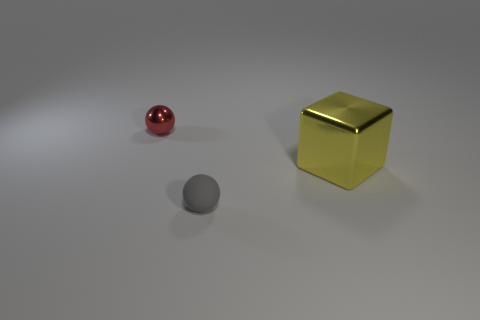Add 2 large shiny blocks. How many objects exist? 5 Subtract all blocks. How many objects are left? 2 Subtract all big brown metal cylinders. Subtract all shiny blocks. How many objects are left? 2 Add 1 big yellow shiny cubes. How many big yellow shiny cubes are left? 2 Add 1 yellow blocks. How many yellow blocks exist? 2 Subtract 0 yellow cylinders. How many objects are left? 3 